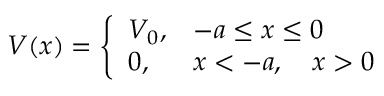Convert formula to latex. <formula><loc_0><loc_0><loc_500><loc_500>V ( x ) = \left \{ \begin{array} { l l } { { V _ { 0 } , } } & { - a \leq x \leq 0 } \\ { 0 , } & { x < - a , \quad x > 0 } \end{array}</formula> 